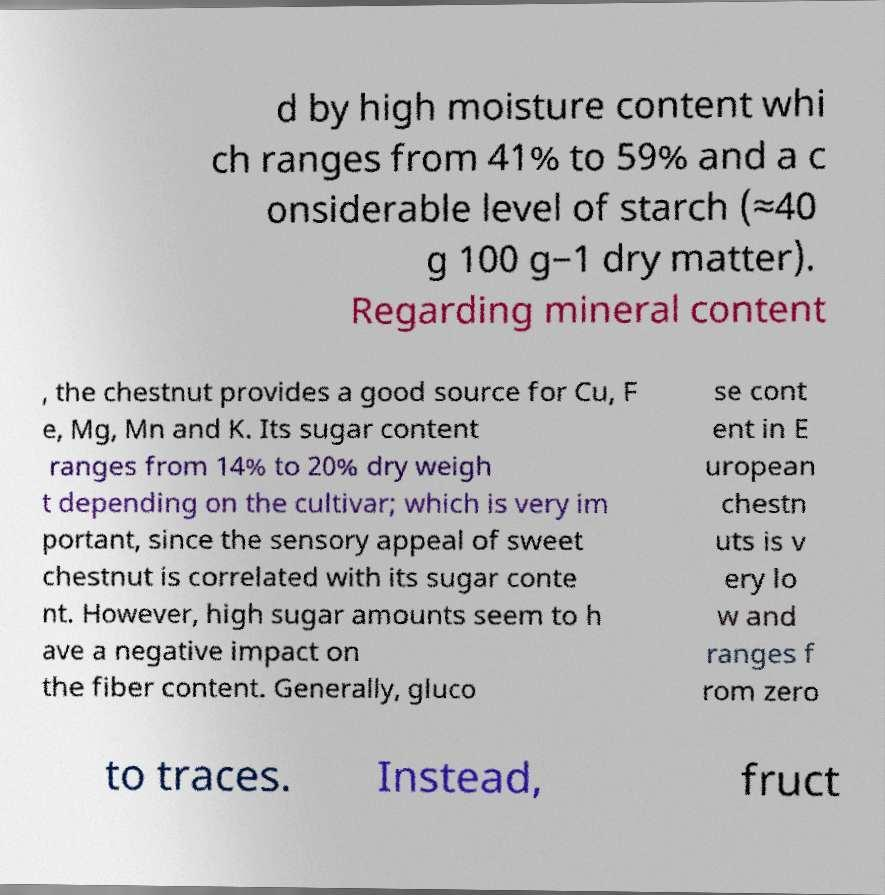There's text embedded in this image that I need extracted. Can you transcribe it verbatim? d by high moisture content whi ch ranges from 41% to 59% and a c onsiderable level of starch (≈40 g 100 g−1 dry matter). Regarding mineral content , the chestnut provides a good source for Cu, F e, Mg, Mn and K. Its sugar content ranges from 14% to 20% dry weigh t depending on the cultivar; which is very im portant, since the sensory appeal of sweet chestnut is correlated with its sugar conte nt. However, high sugar amounts seem to h ave a negative impact on the fiber content. Generally, gluco se cont ent in E uropean chestn uts is v ery lo w and ranges f rom zero to traces. Instead, fruct 